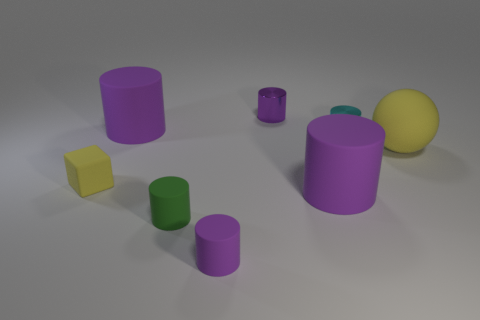Does the large purple object behind the cyan thing have the same shape as the purple shiny object?
Offer a terse response. Yes. What material is the small cyan object?
Your answer should be very brief. Metal. What is the shape of the cyan metallic object that is the same size as the yellow rubber block?
Offer a terse response. Cylinder. Are there any large balls of the same color as the small matte block?
Ensure brevity in your answer.  Yes. There is a rubber sphere; is its color the same as the tiny rubber object behind the small green rubber thing?
Offer a very short reply. Yes. The ball on the right side of the big purple cylinder that is in front of the cube is what color?
Offer a terse response. Yellow. Are there any tiny purple metallic things that are to the right of the metal thing that is right of the tiny purple object behind the tiny block?
Keep it short and to the point. No. What is the color of the block that is the same material as the big yellow sphere?
Ensure brevity in your answer.  Yellow. How many purple objects are made of the same material as the tiny green cylinder?
Provide a short and direct response. 3. Are the big yellow sphere and the tiny purple cylinder that is behind the ball made of the same material?
Ensure brevity in your answer.  No. 